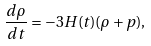<formula> <loc_0><loc_0><loc_500><loc_500>\frac { d \rho } { d t } = - 3 H ( t ) ( \rho + p ) ,</formula> 